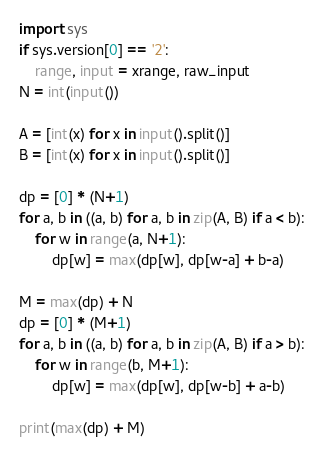Convert code to text. <code><loc_0><loc_0><loc_500><loc_500><_Python_>import sys
if sys.version[0] == '2':
    range, input = xrange, raw_input
N = int(input())

A = [int(x) for x in input().split()]
B = [int(x) for x in input().split()]

dp = [0] * (N+1)
for a, b in ((a, b) for a, b in zip(A, B) if a < b):
    for w in range(a, N+1):
        dp[w] = max(dp[w], dp[w-a] + b-a)

M = max(dp) + N
dp = [0] * (M+1)
for a, b in ((a, b) for a, b in zip(A, B) if a > b):
    for w in range(b, M+1):
        dp[w] = max(dp[w], dp[w-b] + a-b)

print(max(dp) + M)
</code> 